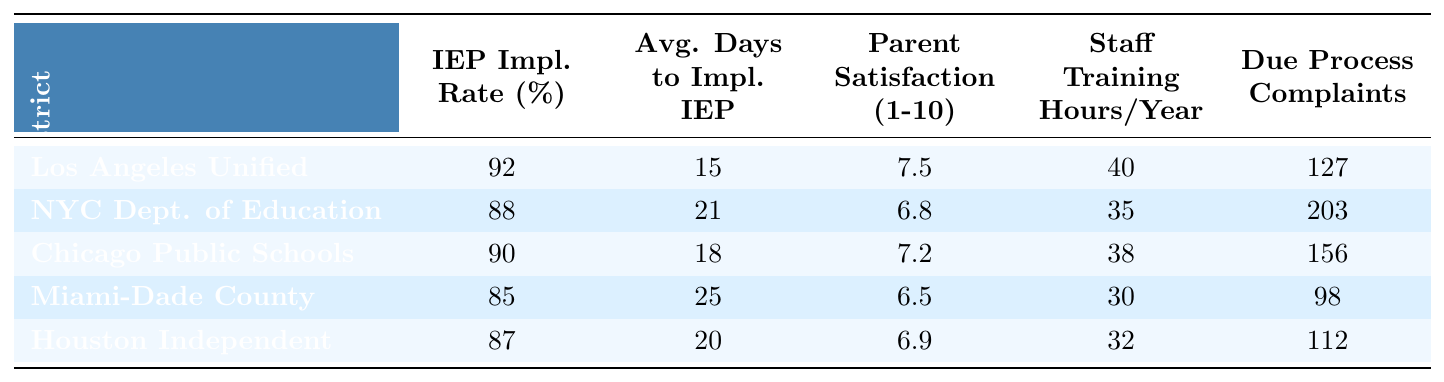What is the IEP implementation rate for Los Angeles Unified? Referring to the row for Los Angeles Unified in the table, the IEP implementation rate is directly listed as 92%.
Answer: 92% Which school district has the highest parent satisfaction score? The parent satisfaction scores listed for each district are 7.5, 6.8, 7.2, 6.5, and 6.9. The highest score is 7.5 for Los Angeles Unified.
Answer: Los Angeles Unified What is the average number of days to implement IEP across all districts? The average can be calculated by summing the days to implement for each district (15 + 21 + 18 + 25 + 20 = 99) and dividing by the number of districts (5), yielding an average of 99/5 = 19.8 days.
Answer: 19.8 Did Miami-Dade County Public Schools have more than 100 due process complaints? The table shows that Miami-Dade County Public Schools had 98 due process complaints, which is less than 100.
Answer: No Which district has the lowest IEP implementation rate? The IEP implementation rates for each district are 92%, 88%, 90%, 85%, and 87%. The lowest is 85% for Miami-Dade County Public Schools.
Answer: Miami-Dade County Public Schools If you take the number of due process complaints for Houston Independent and subtract the number for Chicago Public Schools, what is the result? Houston Independent has 112 due process complaints and Chicago Public Schools has 156. Subtracting gives 112 - 156 = -44.
Answer: -44 What is the relationship between the average days to implement IEP and the IEP implementation rate for New York City Department of Education? New York City has an IEP implementation rate of 88% and an average of 21 days to implement. Although the implementation rate is lower than Los Angeles Unified, the days to implement are longer, suggesting potential delays despite the high approval rates.
Answer: Longer implementation time for lower rate Which district reported the least number of staff training hours per year? The table lists staff training hours per year for each district: 40, 35, 38, 30, and 32. The least is 30 hours for Miami-Dade County Public Schools.
Answer: Miami-Dade County Public Schools What is the difference in the average days to implement IEP between the district with the highest rate and the one with the lowest rate? The highest rate is 92% for Los Angeles Unified (15 days), while the lowest is 85% for Miami-Dade County (25 days). The difference is 25 - 15 = 10 days.
Answer: 10 days Are there any districts with a parent satisfaction score above 7? The parent satisfaction scores are 7.5, 6.8, 7.2, 6.5, and 6.9. Only Los Angeles Unified has a score above 7 (7.5).
Answer: Yes, Los Angeles Unified 